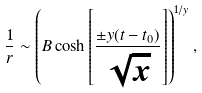Convert formula to latex. <formula><loc_0><loc_0><loc_500><loc_500>\frac { 1 } { r } \sim \left ( B \cosh \left [ \frac { \pm y ( t - t _ { 0 } ) } { \sqrt { x } } \right ] \right ) ^ { 1 / y } ,</formula> 